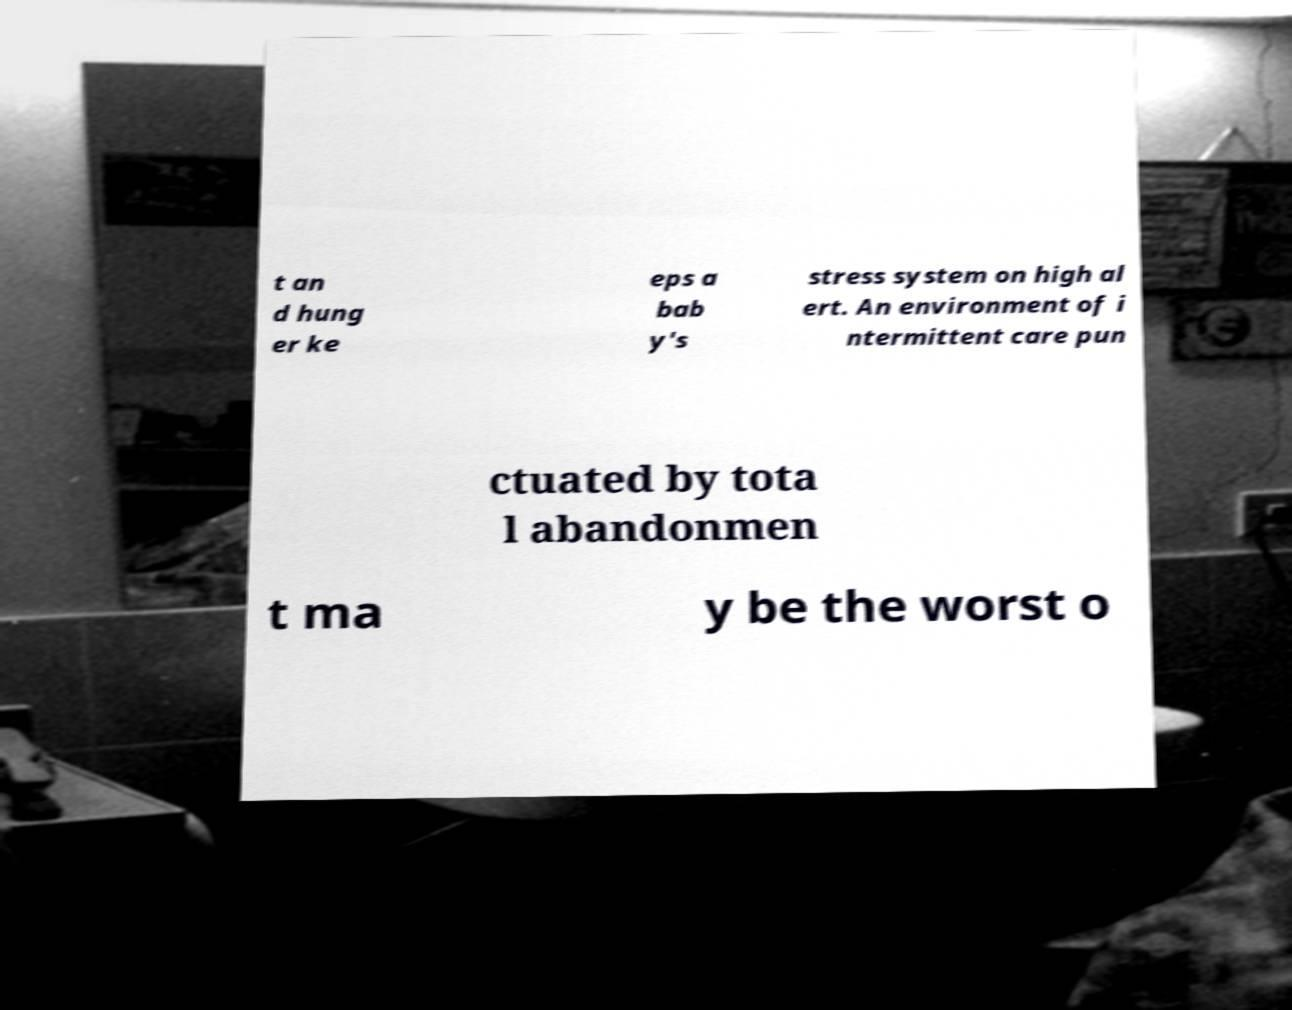Could you assist in decoding the text presented in this image and type it out clearly? t an d hung er ke eps a bab y's stress system on high al ert. An environment of i ntermittent care pun ctuated by tota l abandonmen t ma y be the worst o 